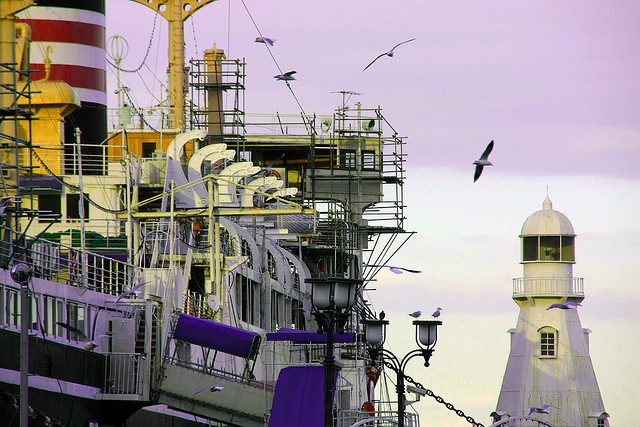Describe the objects in this image and their specific colors. I can see bird in olive, darkgray, black, and gray tones, bird in olive, black, gray, and purple tones, bird in olive, black, gray, darkgray, and violet tones, bird in olive, darkgray, purple, and gray tones, and bird in olive, lavender, gray, and pink tones in this image. 